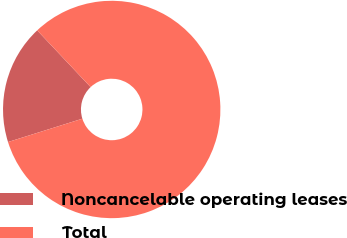Convert chart. <chart><loc_0><loc_0><loc_500><loc_500><pie_chart><fcel>Noncancelable operating leases<fcel>Total<nl><fcel>17.82%<fcel>82.18%<nl></chart> 